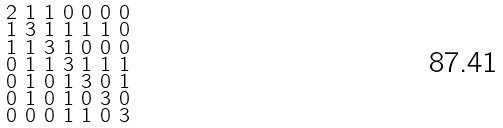Convert formula to latex. <formula><loc_0><loc_0><loc_500><loc_500>\begin{smallmatrix} 2 & 1 & 1 & 0 & 0 & 0 & 0 \\ 1 & 3 & 1 & 1 & 1 & 1 & 0 \\ 1 & 1 & 3 & 1 & 0 & 0 & 0 \\ 0 & 1 & 1 & 3 & 1 & 1 & 1 \\ 0 & 1 & 0 & 1 & 3 & 0 & 1 \\ 0 & 1 & 0 & 1 & 0 & 3 & 0 \\ 0 & 0 & 0 & 1 & 1 & 0 & 3 \end{smallmatrix}</formula> 